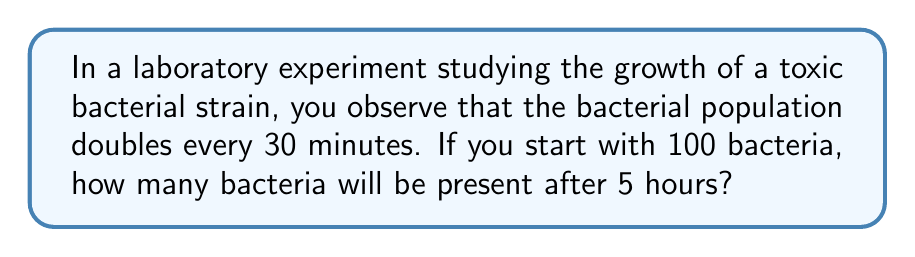Show me your answer to this math problem. Let's approach this step-by-step:

1) First, we need to determine how many doubling periods occur in 5 hours:
   5 hours = 300 minutes
   Number of doubling periods = 300 minutes ÷ 30 minutes = 10

2) Now, we can express this as an exponential growth problem:
   Final population = Initial population × 2^(number of doubling periods)

3) Let's plug in our values:
   Final population = 100 × 2^10

4) To calculate 2^10:
   2^10 = 2 × 2 × 2 × 2 × 2 × 2 × 2 × 2 × 2 × 2 = 1024

5) Therefore:
   Final population = 100 × 1024 = 102,400

Thus, after 5 hours, the bacterial population will be 102,400.

This can be expressed mathematically as:

$$N = N_0 \times 2^{t/T}$$

Where:
$N$ = Final population
$N_0$ = Initial population (100)
$t$ = Total time (300 minutes)
$T$ = Doubling time (30 minutes)

Plugging in our values:

$$N = 100 \times 2^{300/30} = 100 \times 2^{10} = 100 \times 1024 = 102,400$$
Answer: 102,400 bacteria 